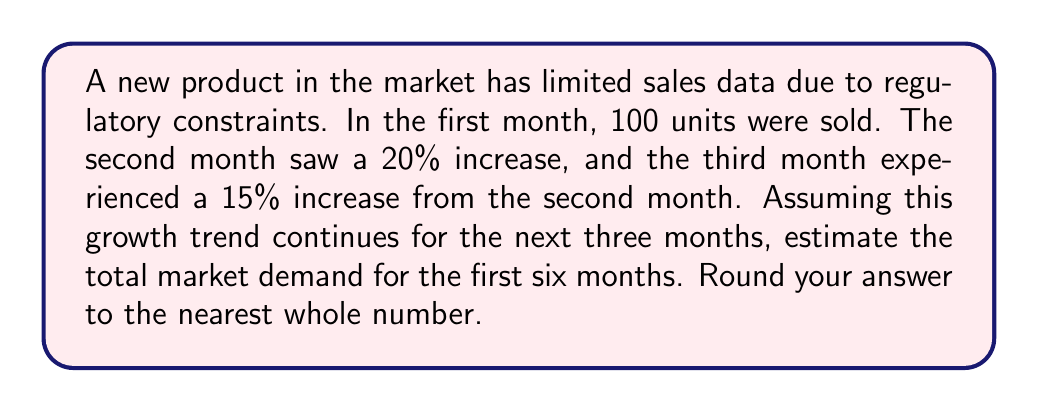Can you solve this math problem? Let's approach this step-by-step:

1) First month sales: 100 units

2) Second month sales:
   $100 \times (1 + 0.20) = 100 \times 1.20 = 120$ units

3) Third month sales:
   $120 \times (1 + 0.15) = 120 \times 1.15 = 138$ units

4) We can see that the growth rate is not constant, but let's assume it continues at 15% for the next three months:

   Fourth month: $138 \times 1.15 = 158.7$ units
   Fifth month: $158.7 \times 1.15 = 182.505$ units
   Sixth month: $182.505 \times 1.15 = 209.88075$ units

5) Now, let's sum up the sales for all six months:

   $$\text{Total} = 100 + 120 + 138 + 158.7 + 182.505 + 209.88075$$
   $$= 908.58575$$

6) Rounding to the nearest whole number:
   $$908.58575 \approx 909$$

Therefore, the estimated total market demand for the first six months is 909 units.
Answer: 909 units 